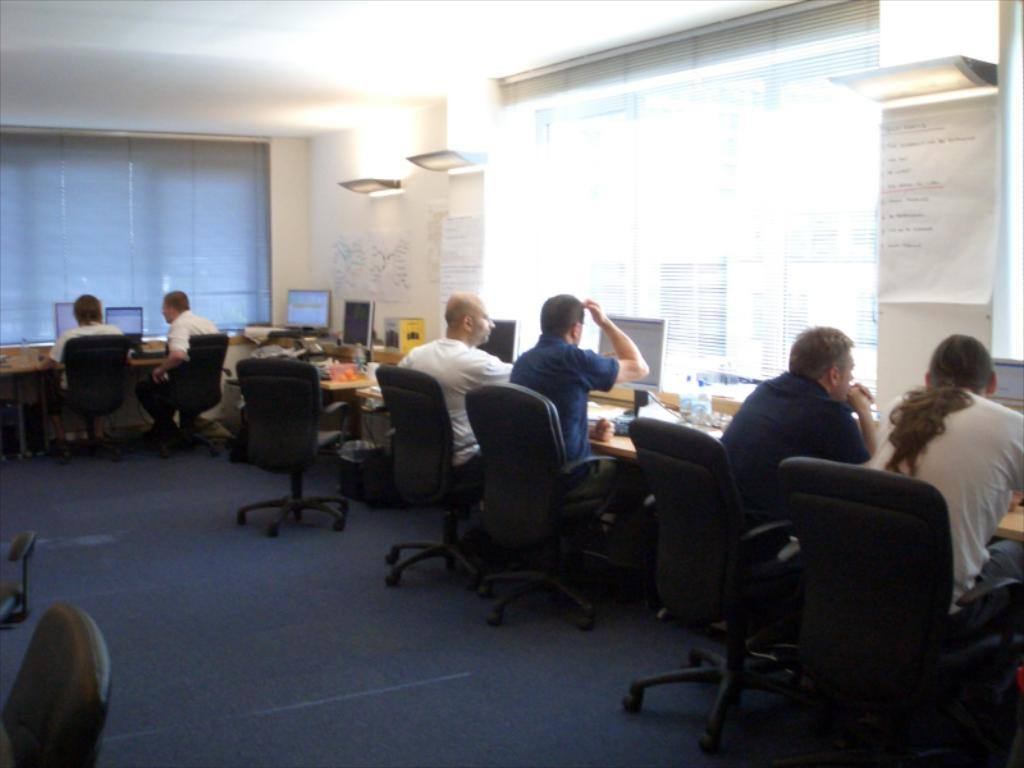What are the people in the image doing? The people in the image are sitting on a table and operating their monitors. Can you describe the setting in which the people are working? The setting is not specified, but the people are sitting at a table. What else can be seen in the image besides the people and their monitors? There are few unspecified elements in the background. What type of insurance policy do the people in the image have for their property? There is no information about insurance policies or property in the image. 